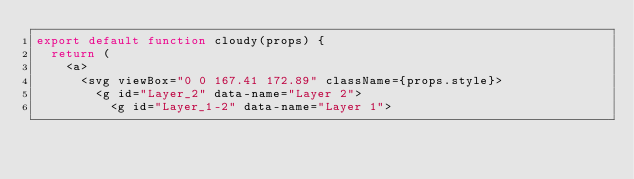<code> <loc_0><loc_0><loc_500><loc_500><_JavaScript_>export default function cloudy(props) {
  return (
    <a>
      <svg viewBox="0 0 167.41 172.89" className={props.style}>
        <g id="Layer_2" data-name="Layer 2">
          <g id="Layer_1-2" data-name="Layer 1"></code> 